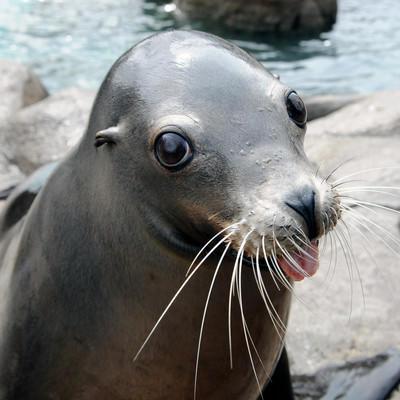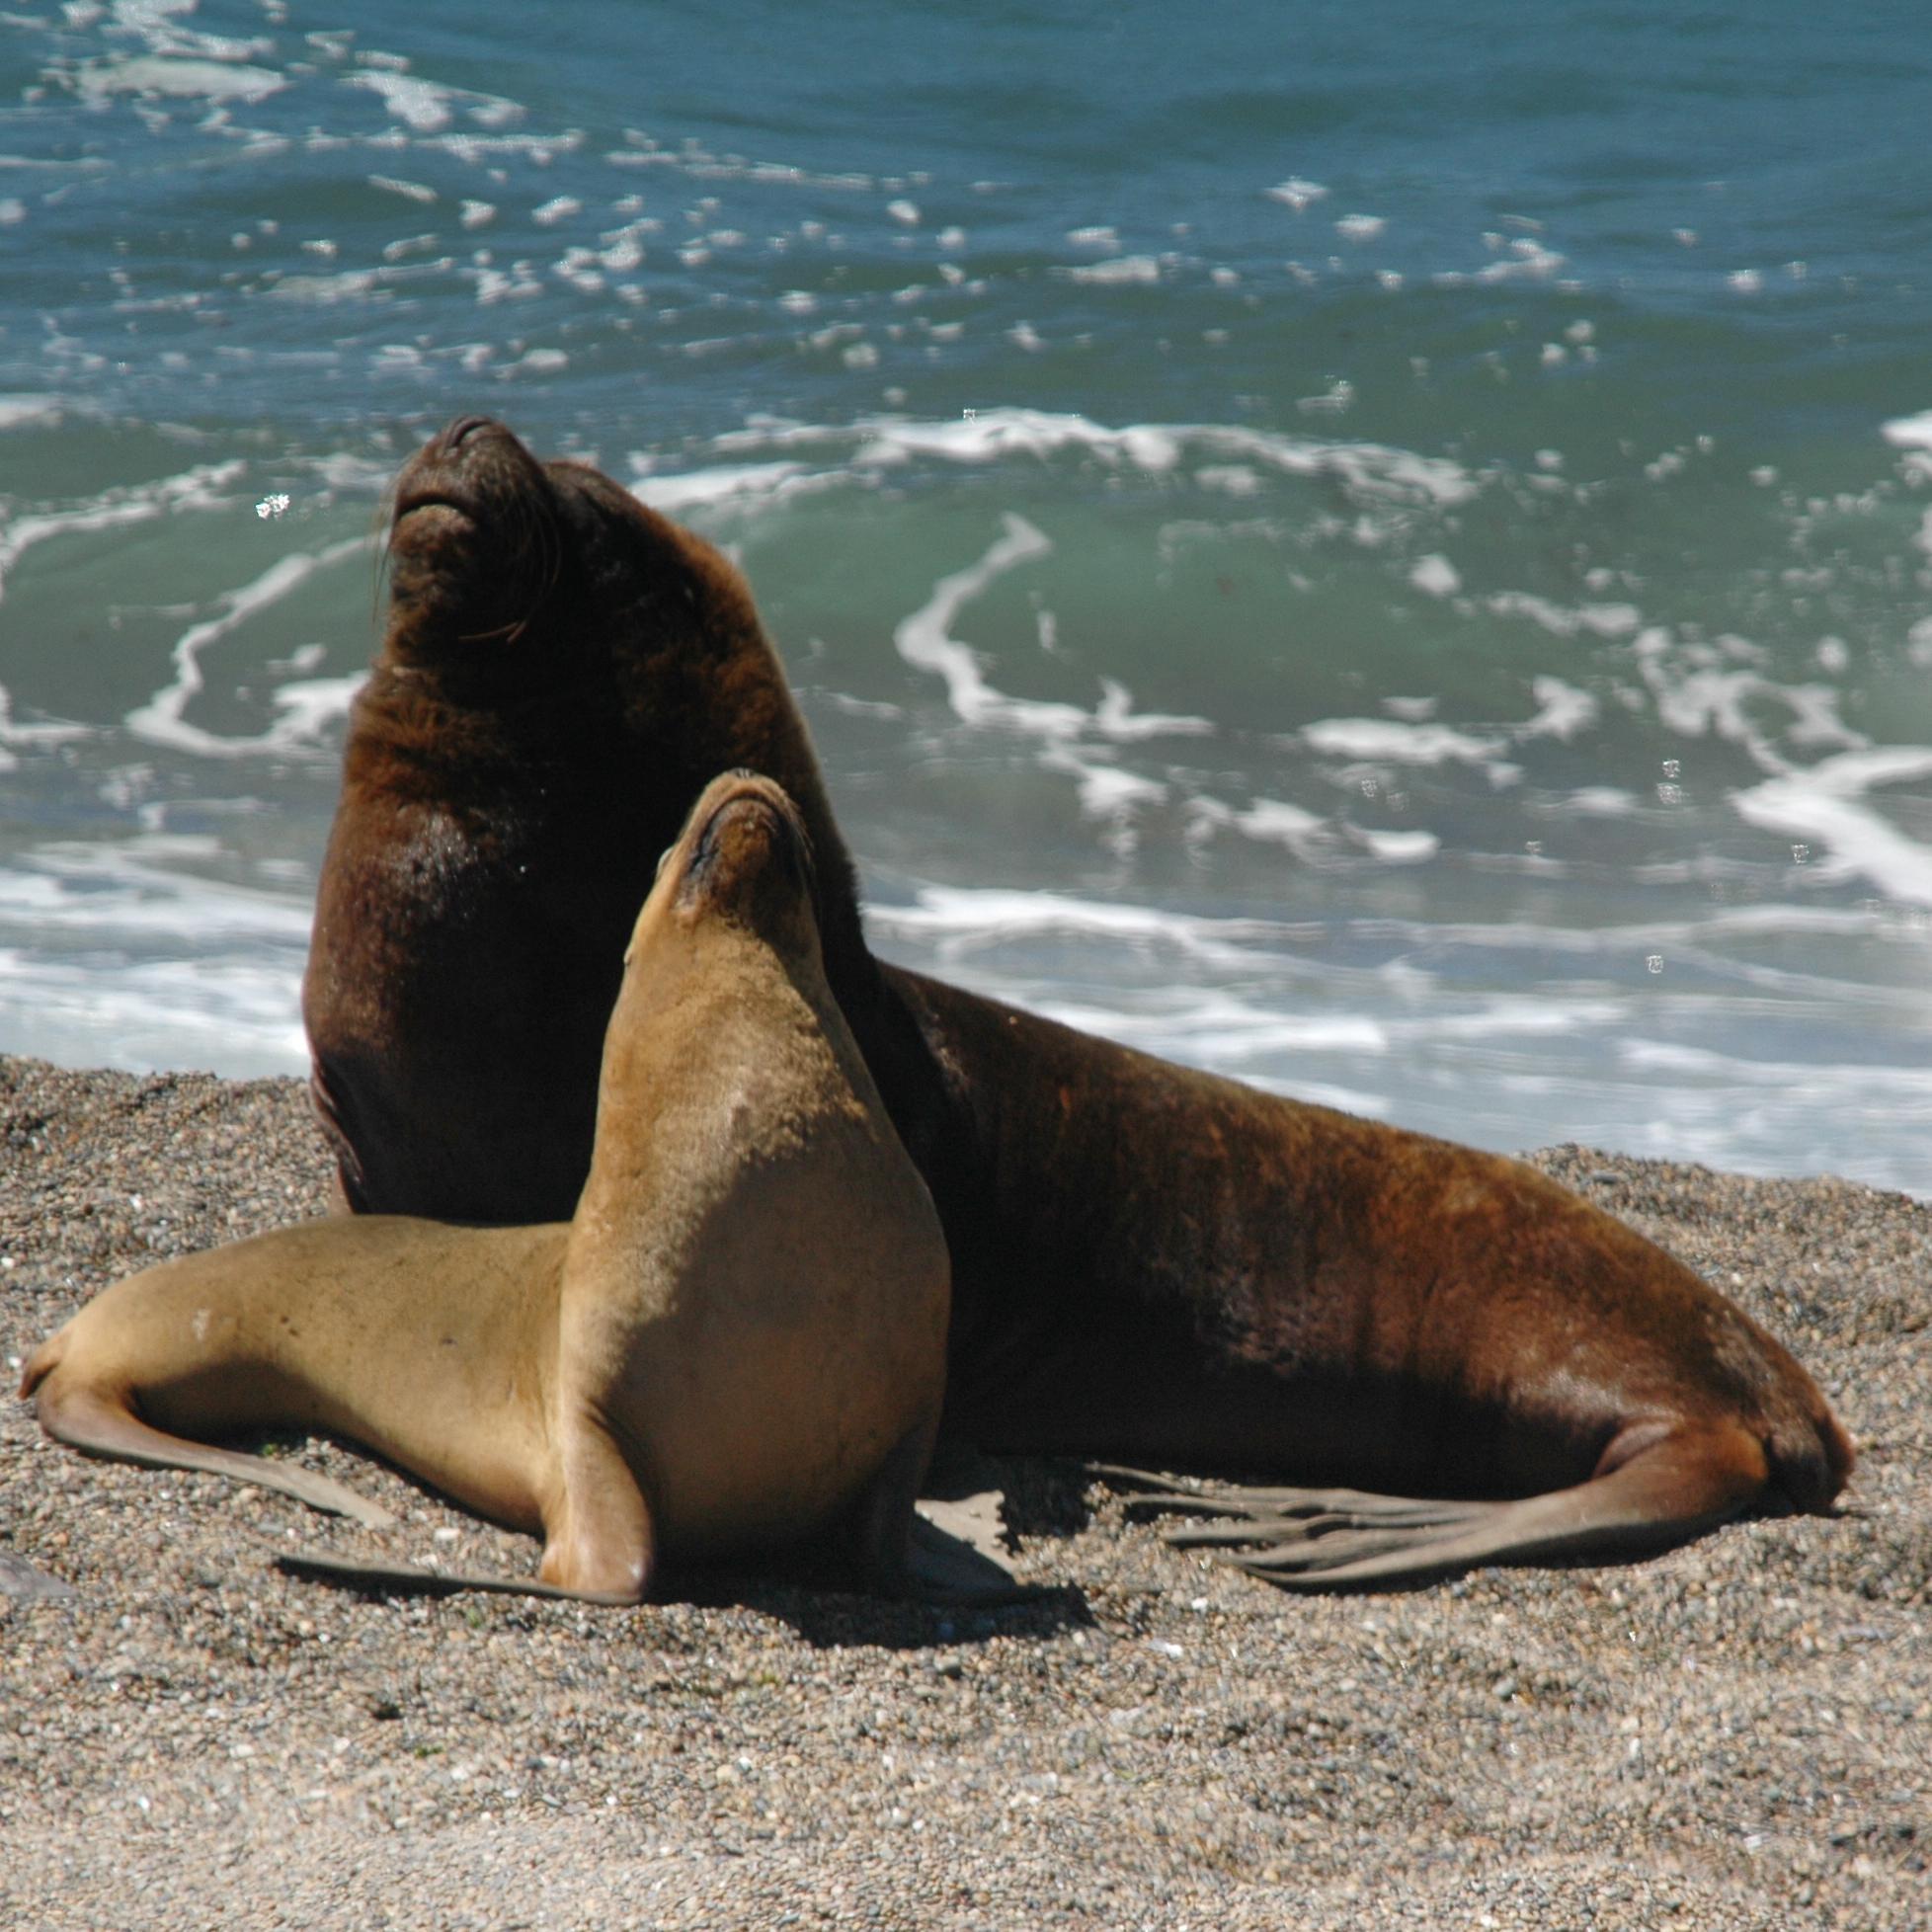The first image is the image on the left, the second image is the image on the right. For the images shown, is this caption "There is a bird in the image on the left." true? Answer yes or no. No. The first image is the image on the left, the second image is the image on the right. Assess this claim about the two images: "Right image shows a seal on rocks in the center with a smaller animal to the left.". Correct or not? Answer yes or no. No. 